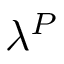Convert formula to latex. <formula><loc_0><loc_0><loc_500><loc_500>\lambda ^ { P }</formula> 